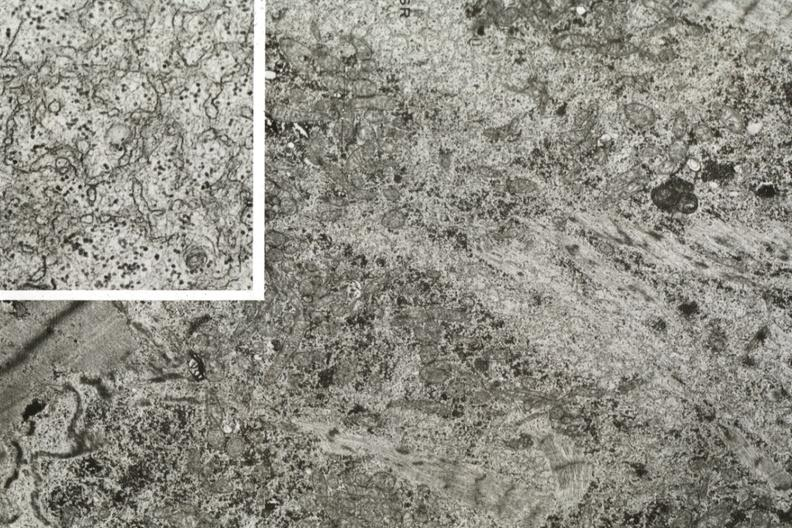what is present?
Answer the question using a single word or phrase. Atrophy 